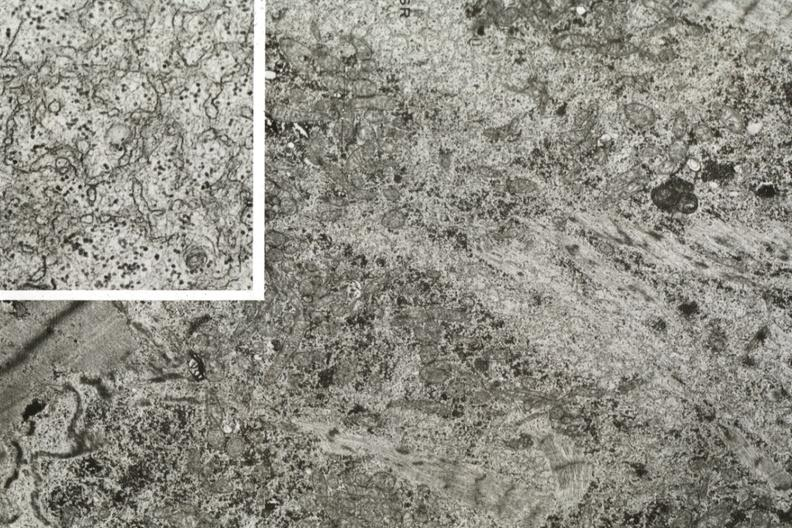what is present?
Answer the question using a single word or phrase. Atrophy 